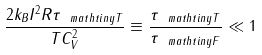Convert formula to latex. <formula><loc_0><loc_0><loc_500><loc_500>\frac { 2 k _ { B } I ^ { 2 } R \tau _ { \ m a t h t i n y T } } { T C _ { V } ^ { 2 } } \equiv \frac { \tau _ { \ m a t h t i n y T } } { \tau _ { \ m a t h t i n y F } } \ll 1</formula> 